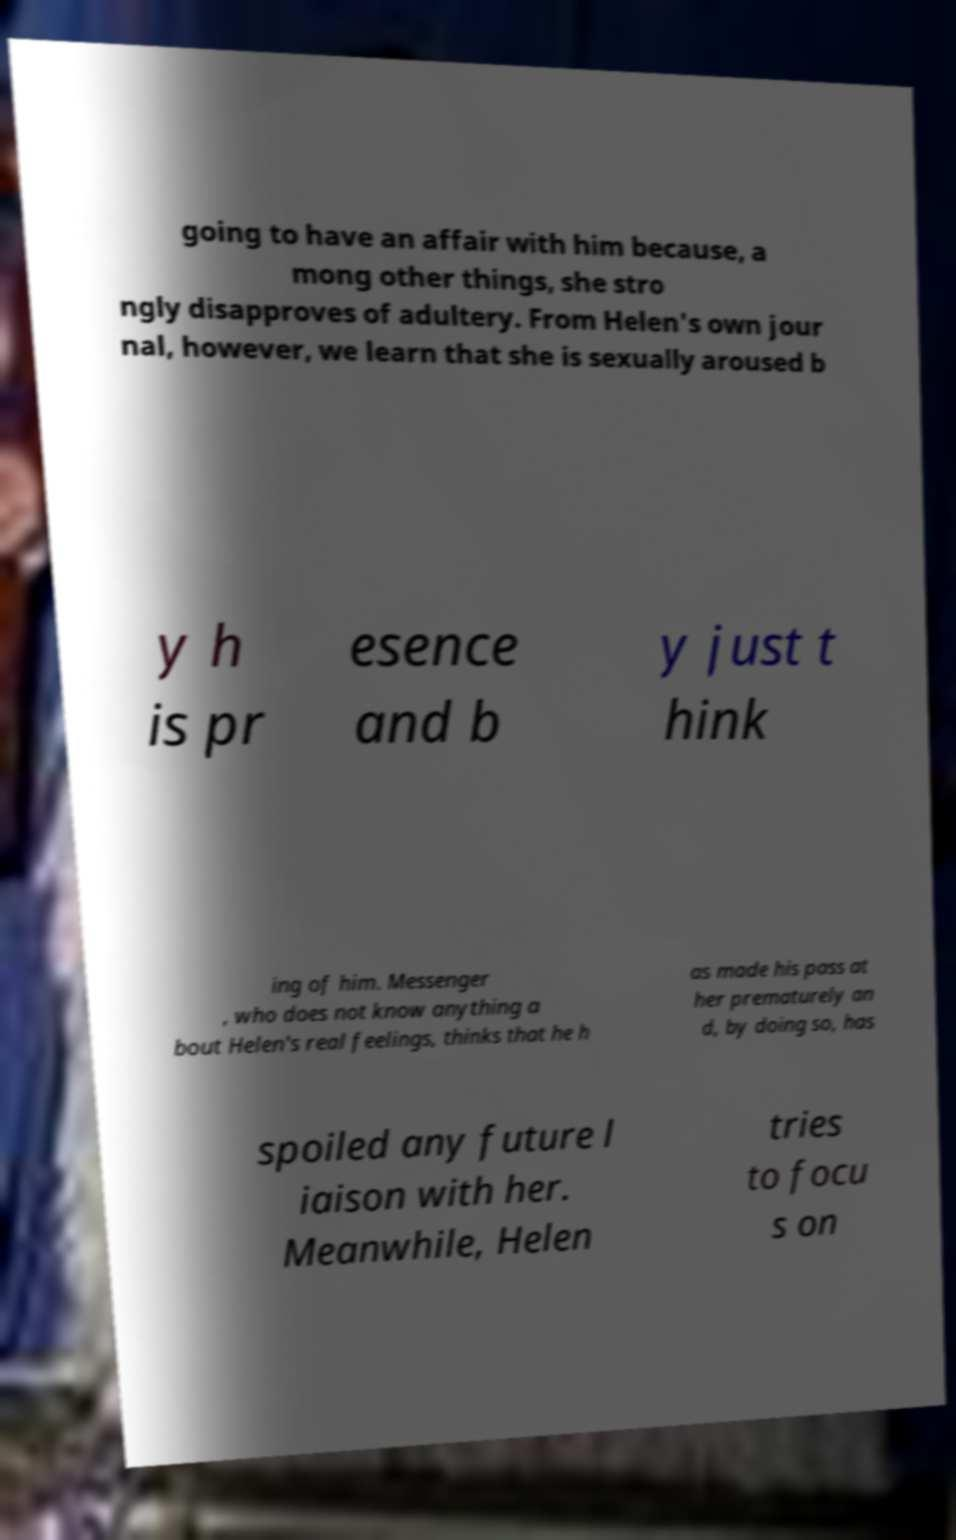There's text embedded in this image that I need extracted. Can you transcribe it verbatim? going to have an affair with him because, a mong other things, she stro ngly disapproves of adultery. From Helen's own jour nal, however, we learn that she is sexually aroused b y h is pr esence and b y just t hink ing of him. Messenger , who does not know anything a bout Helen's real feelings, thinks that he h as made his pass at her prematurely an d, by doing so, has spoiled any future l iaison with her. Meanwhile, Helen tries to focu s on 